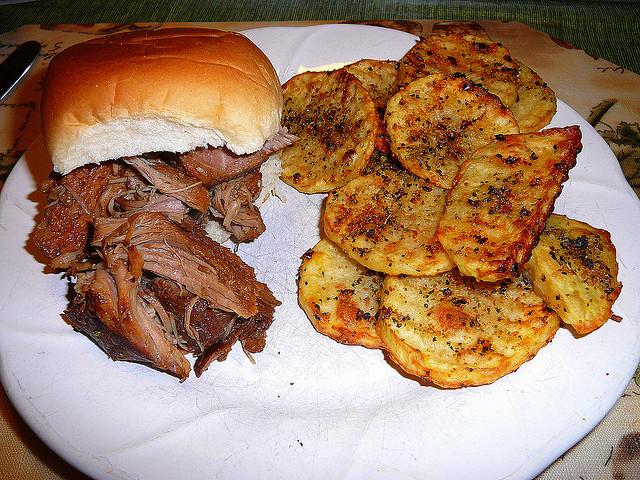The item on the right is most likely a cooked version of what? Please explain your reasoning. potato. The potatoes are sliced and fried. 